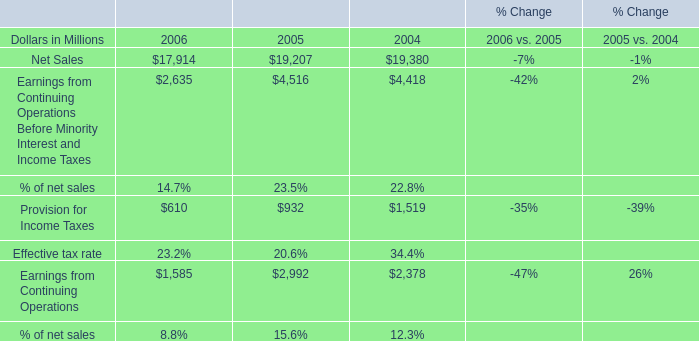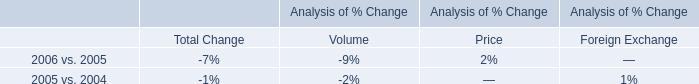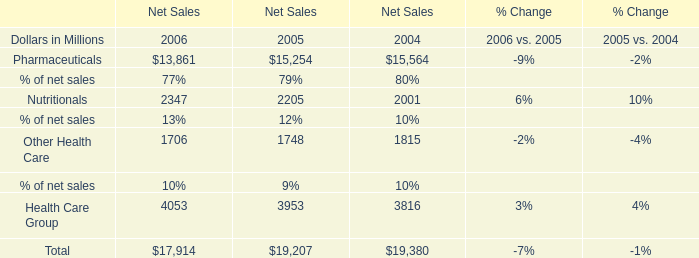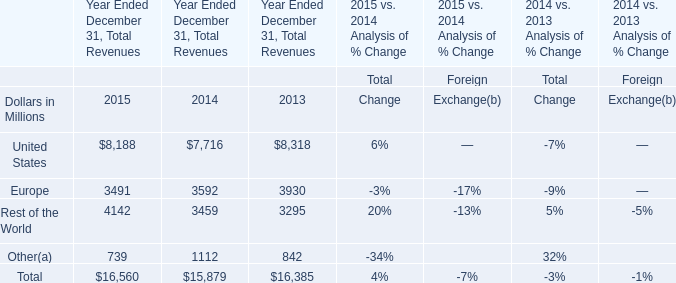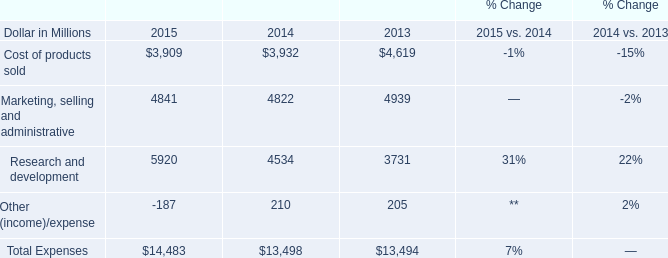What's the average of Net Sales in 2006, 2005, and 2004? (in million) 
Computations: (((17914 + 19207) + 19380) / 3)
Answer: 18833.66667. 